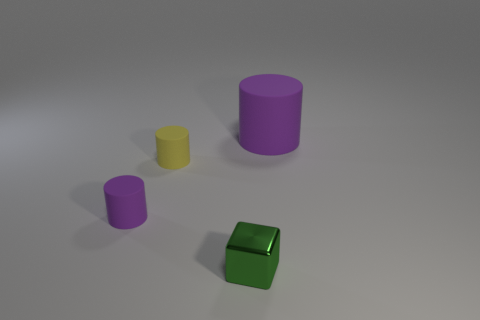What can you tell me about the lighting and shadows in the image? The lighting in the image appears to be coming from above, casting soft shadows directly underneath each object. The shadows are not very long or dark, indicating the light source may not be very close or is diffused, possibly simulating an overcast day or indoor lighting. 